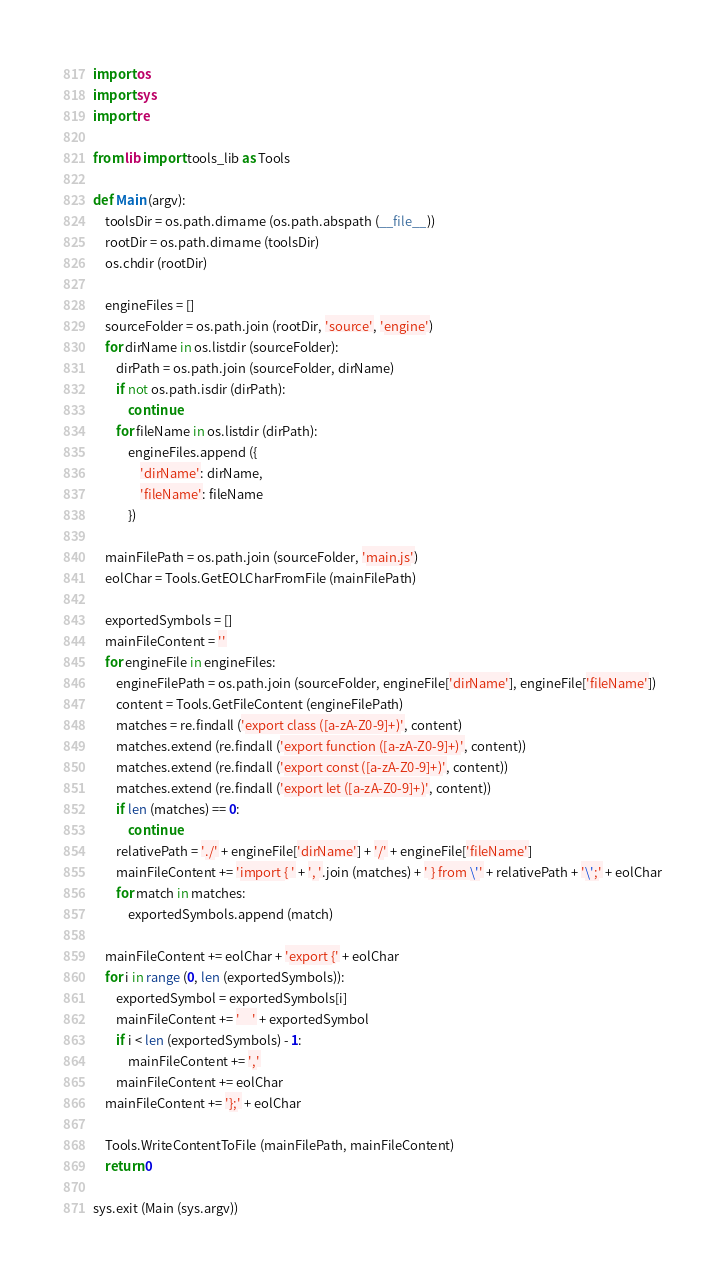<code> <loc_0><loc_0><loc_500><loc_500><_Python_>import os
import sys
import re

from lib import tools_lib as Tools

def Main (argv):
	toolsDir = os.path.dirname (os.path.abspath (__file__))
	rootDir = os.path.dirname (toolsDir)
	os.chdir (rootDir)

	engineFiles = []
	sourceFolder = os.path.join (rootDir, 'source', 'engine')
	for dirName in os.listdir (sourceFolder):
		dirPath = os.path.join (sourceFolder, dirName)
		if not os.path.isdir (dirPath):
			continue
		for fileName in os.listdir (dirPath):
			engineFiles.append ({
				'dirName': dirName,
				'fileName': fileName
			})

	mainFilePath = os.path.join (sourceFolder, 'main.js')
	eolChar = Tools.GetEOLCharFromFile (mainFilePath)

	exportedSymbols = []
	mainFileContent = ''
	for engineFile in engineFiles:
		engineFilePath = os.path.join (sourceFolder, engineFile['dirName'], engineFile['fileName'])
		content = Tools.GetFileContent (engineFilePath)
		matches = re.findall ('export class ([a-zA-Z0-9]+)', content)
		matches.extend (re.findall ('export function ([a-zA-Z0-9]+)', content))
		matches.extend (re.findall ('export const ([a-zA-Z0-9]+)', content))
		matches.extend (re.findall ('export let ([a-zA-Z0-9]+)', content))
		if len (matches) == 0:
			continue
		relativePath = './' + engineFile['dirName'] + '/' + engineFile['fileName']
		mainFileContent += 'import { ' + ', '.join (matches) + ' } from \'' + relativePath + '\';' + eolChar
		for match in matches:
			exportedSymbols.append (match)

	mainFileContent += eolChar + 'export {' + eolChar
	for i in range (0, len (exportedSymbols)):
		exportedSymbol = exportedSymbols[i]
		mainFileContent += '    ' + exportedSymbol
		if i < len (exportedSymbols) - 1:
			mainFileContent += ','
		mainFileContent += eolChar
	mainFileContent += '};' + eolChar

	Tools.WriteContentToFile (mainFilePath, mainFileContent)
	return 0

sys.exit (Main (sys.argv))
</code> 